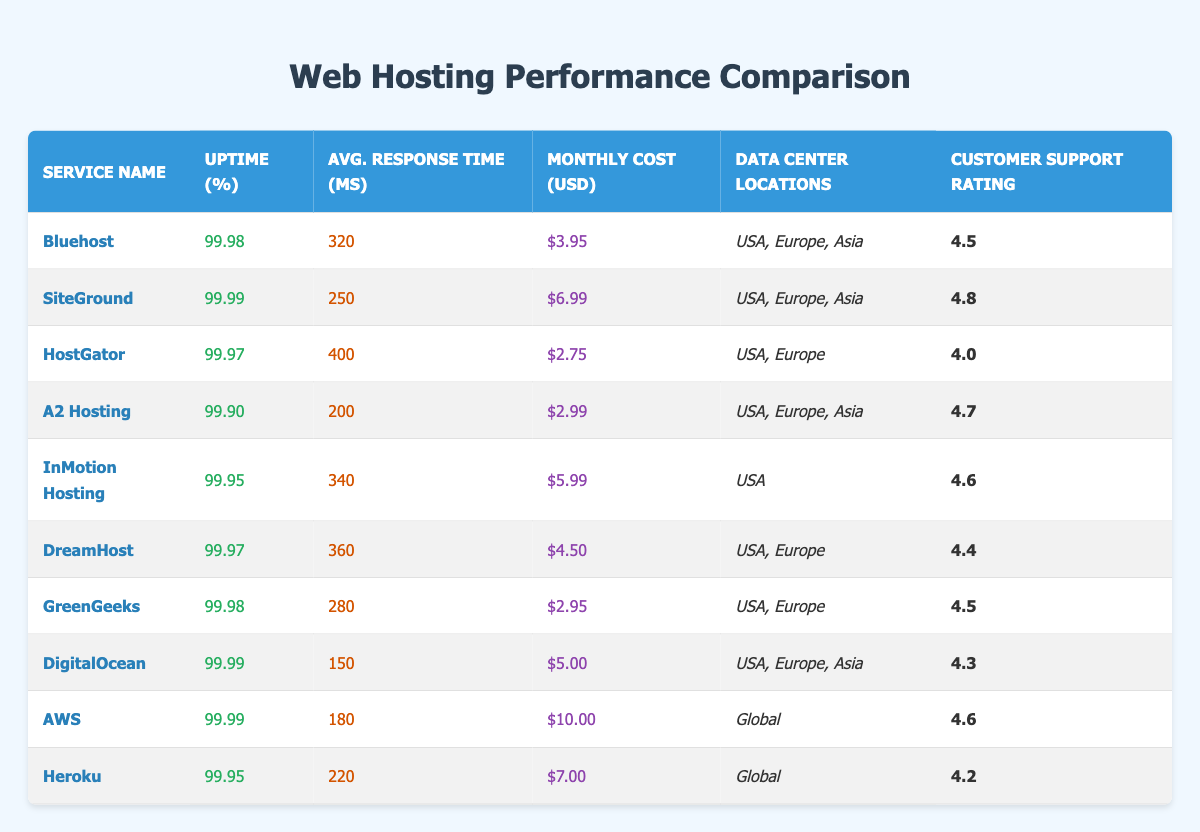What is the uptime percentage for SiteGround? In the table, I can find the row for SiteGround. The uptime percentage is listed as 99.99%.
Answer: 99.99 Which web hosting service has the lowest monthly cost? By looking at the monthly cost column, the lowest value is for HostGator at $2.75.
Answer: $2.75 What is the average response time of all hosting services combined? I gather the average response time by adding all the average response times (320 + 250 + 400 + 200 + 340 + 360 + 280 + 150 + 180 + 220 = 2650) and divide by the number of services (10). Thus, the average response time is 2650 / 10 = 265 ms.
Answer: 265 Is the customer support rating for DigitalOcean higher than for GreenGeeks? I compare the two customer support ratings from the table: DigitalOcean has a rating of 4.3 and GreenGeeks has a rating of 4.5. Since 4.3 is not higher than 4.5, the answer is false.
Answer: No Which service has the highest customer support rating, and how does it compare to the next highest? I examine the customer support ratings and find that SiteGround has the highest rating of 4.8. The next highest is A2 Hosting with a rating of 4.7, which is only 0.1 lower than SiteGround's rating.
Answer: SiteGround (4.8) What is the total uptime percentage for all services? Since uptime percentages are not directly additive, I find the average uptime percentage instead, which involves summing all uptime percentages (99.98 + 99.99 + 99.97 + 99.90 + 99.95 + 99.97 + 99.98 + 99.99 + 99.99 + 99.95 = 999.88) and dividing by 10, giving an average of 99.988%.
Answer: 99.988 Are there more data center locations for Bluehost than for AWS? Bluehost has three data center locations (USA, Europe, Asia) while AWS has one (Global). This means Bluehost does have more locations.
Answer: Yes Which hosting service offers the best combination of cost and customer support rating? I assess the monthly costs and customer support ratings by calculating the cost per customer support point. SiteGround’s combination yields ($6.99 / 4.8 = 1.45), A2 Hosting’s ($2.99 / 4.7 = 0.64), and DigitalOcean ($5.00 / 4.3 = 1.16). A2 Hosting offers the best value with the lowest cost relative to customer support quality.
Answer: A2 Hosting 